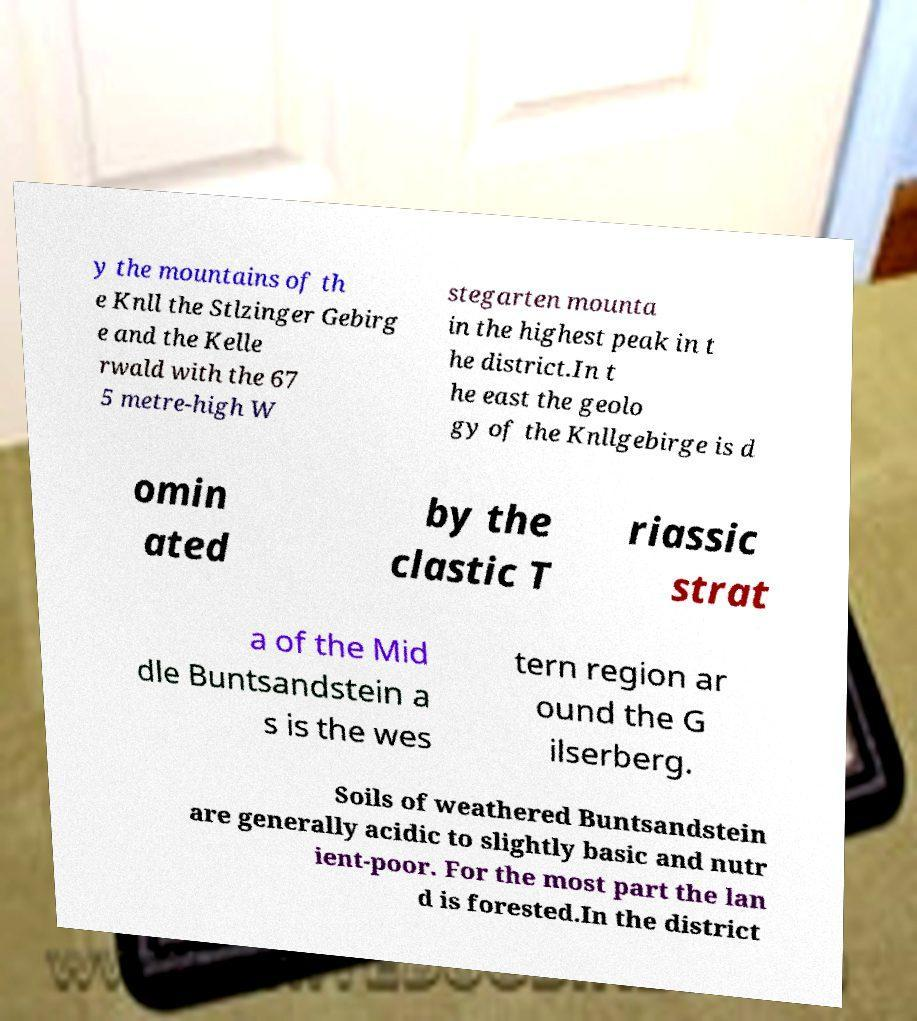Could you extract and type out the text from this image? y the mountains of th e Knll the Stlzinger Gebirg e and the Kelle rwald with the 67 5 metre-high W stegarten mounta in the highest peak in t he district.In t he east the geolo gy of the Knllgebirge is d omin ated by the clastic T riassic strat a of the Mid dle Buntsandstein a s is the wes tern region ar ound the G ilserberg. Soils of weathered Buntsandstein are generally acidic to slightly basic and nutr ient-poor. For the most part the lan d is forested.In the district 